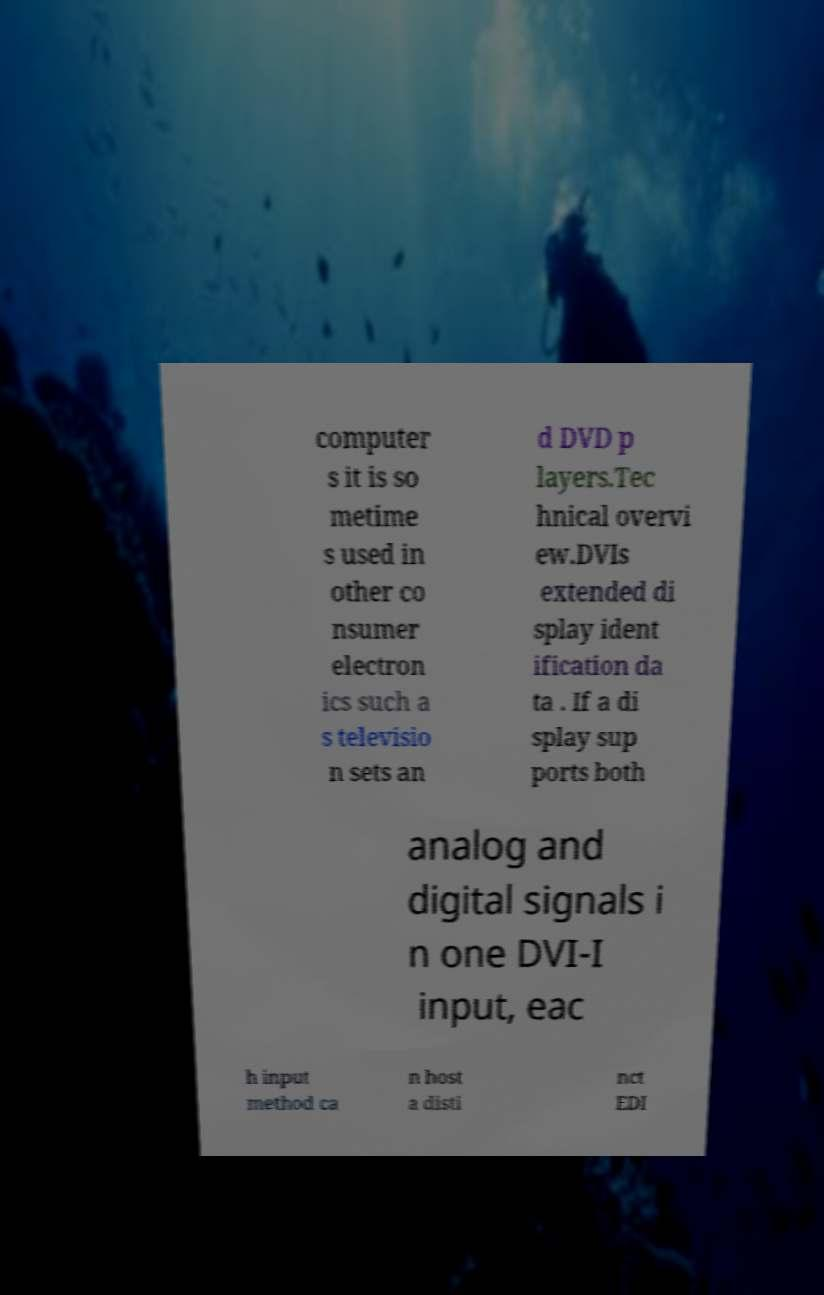Please read and relay the text visible in this image. What does it say? computer s it is so metime s used in other co nsumer electron ics such a s televisio n sets an d DVD p layers.Tec hnical overvi ew.DVIs extended di splay ident ification da ta . If a di splay sup ports both analog and digital signals i n one DVI-I input, eac h input method ca n host a disti nct EDI 